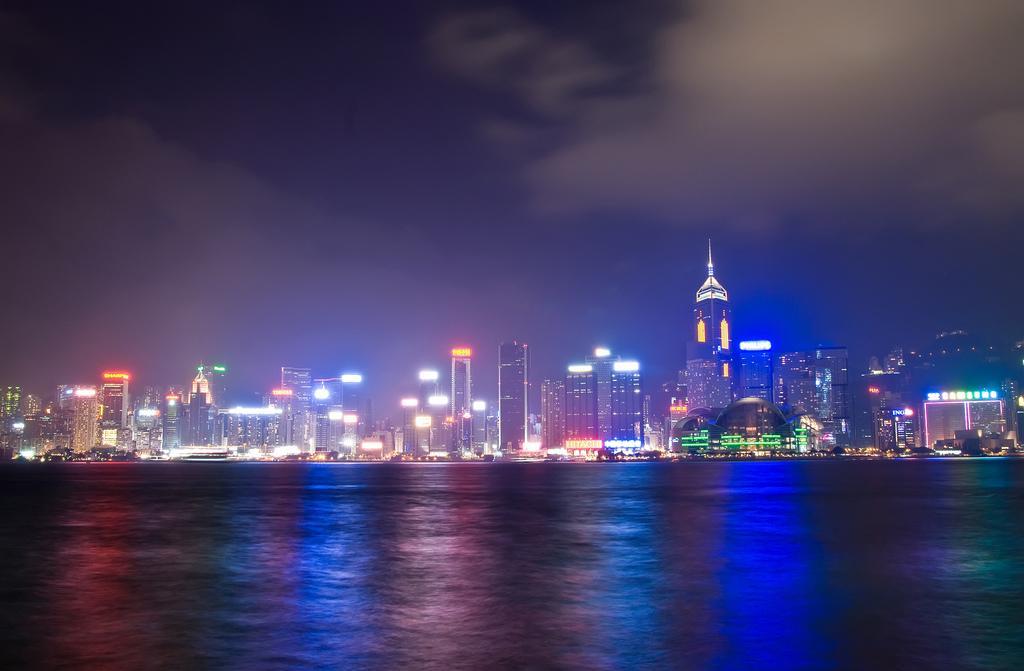Can you describe this image briefly? At the bottom of the picture, we see water and this water might be in the river. There are buildings, streetlights and the poles in the background. At the top, we see the sky and the clouds. This picture might be clicked in the dark. 